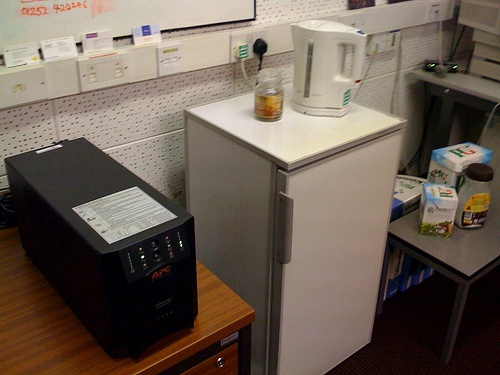Describe the objects in this image and their specific colors. I can see refrigerator in darkgray and gray tones, bottle in darkgray, tan, olive, and gray tones, and book in darkgray, gray, and black tones in this image. 